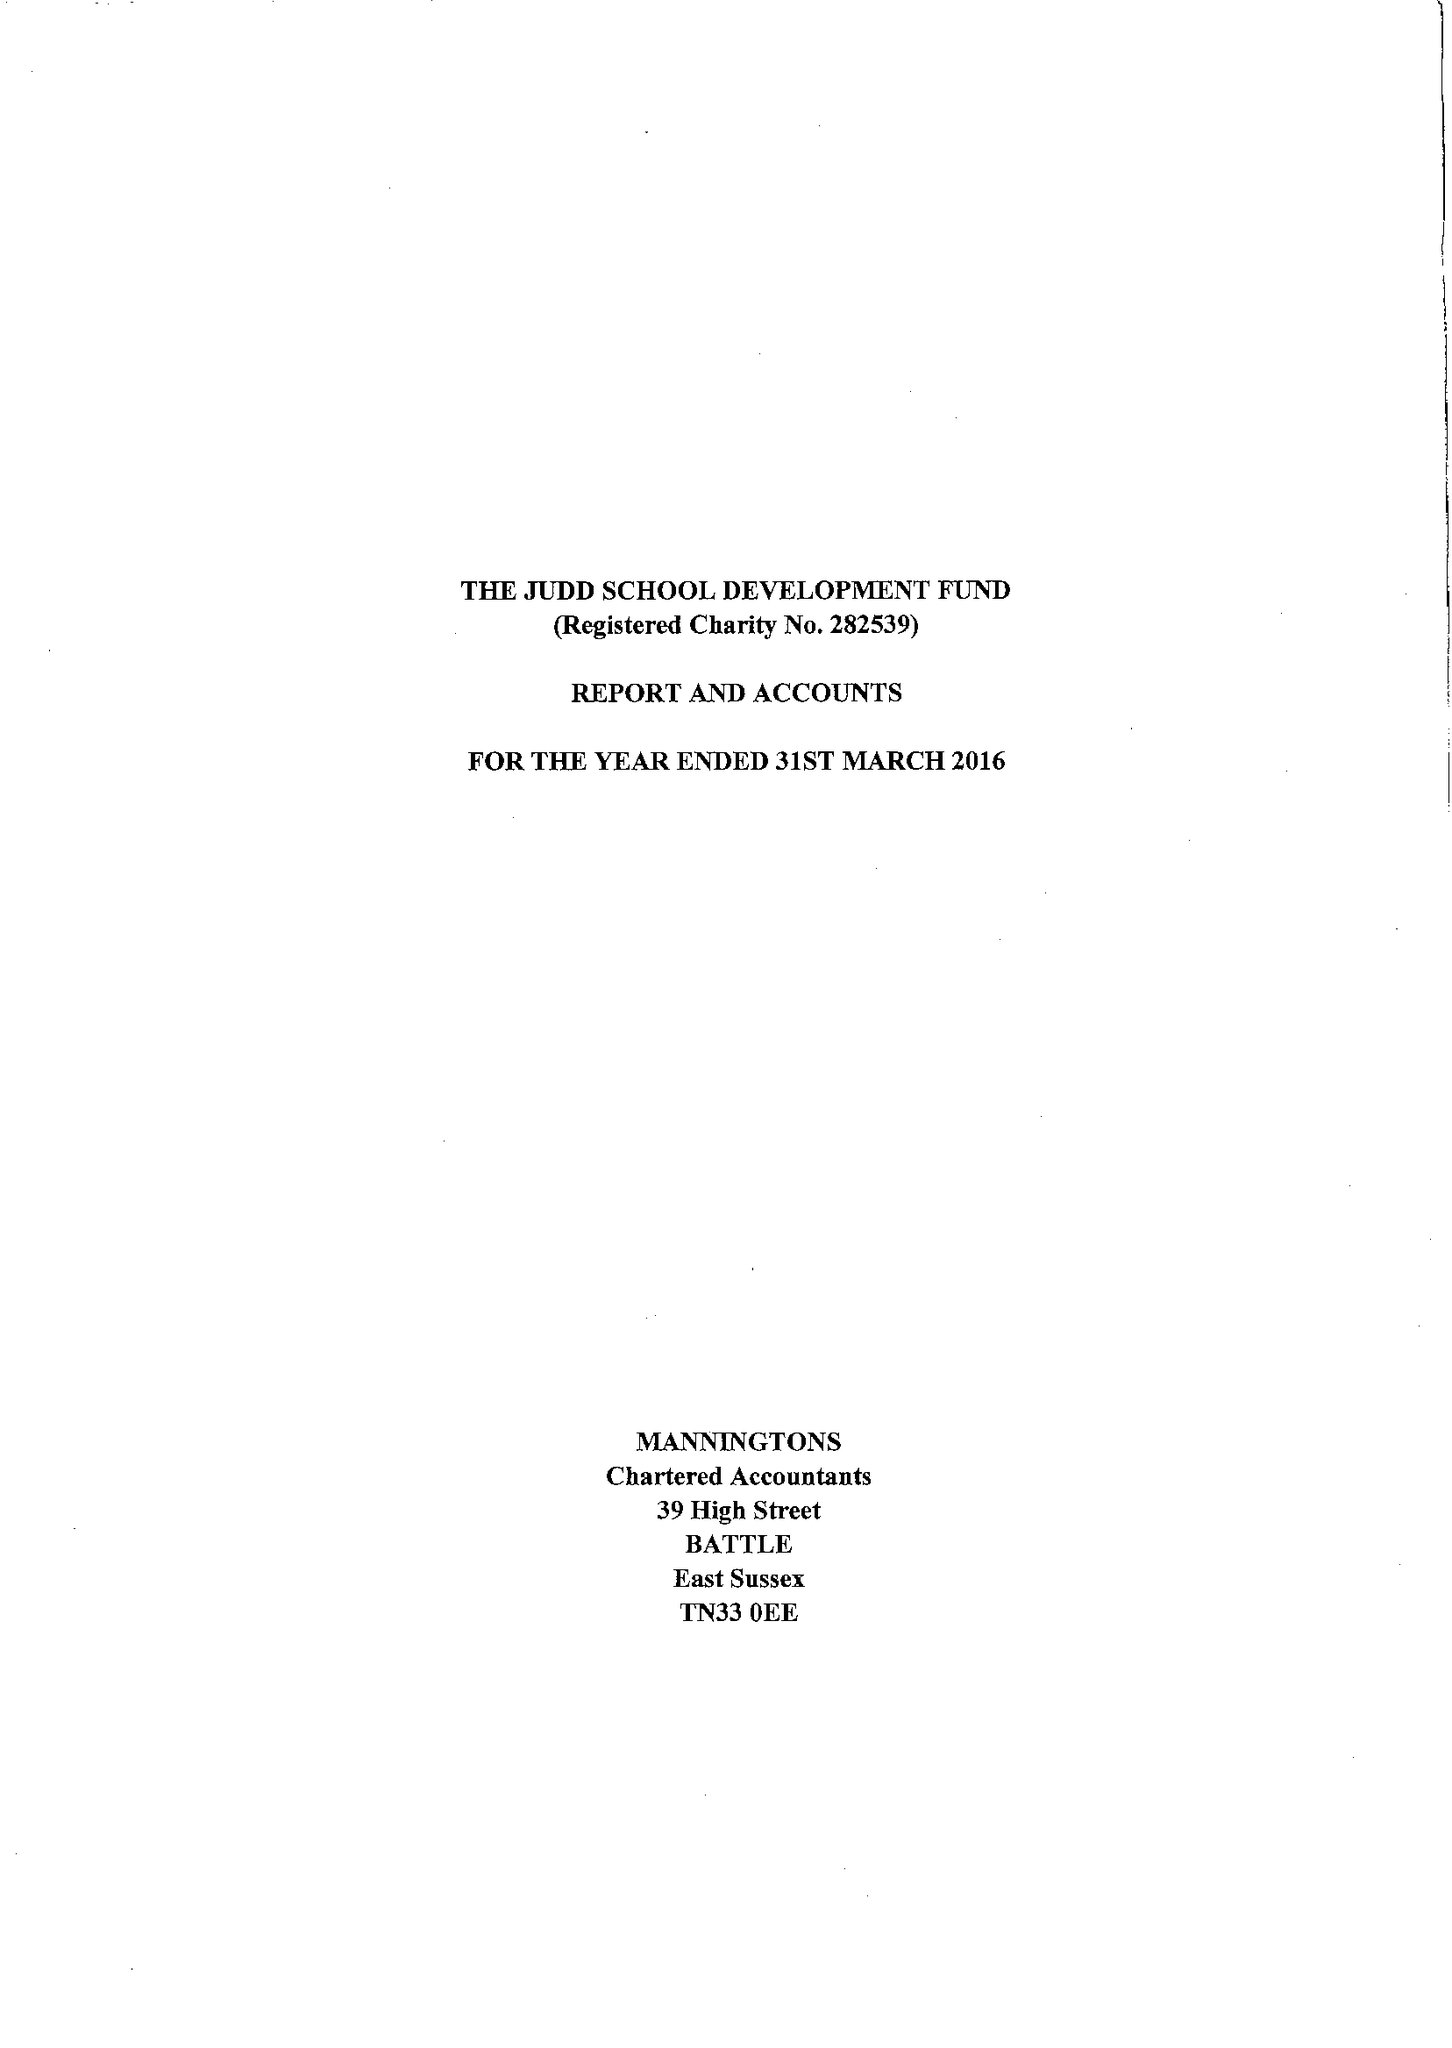What is the value for the spending_annually_in_british_pounds?
Answer the question using a single word or phrase. 37550.00 